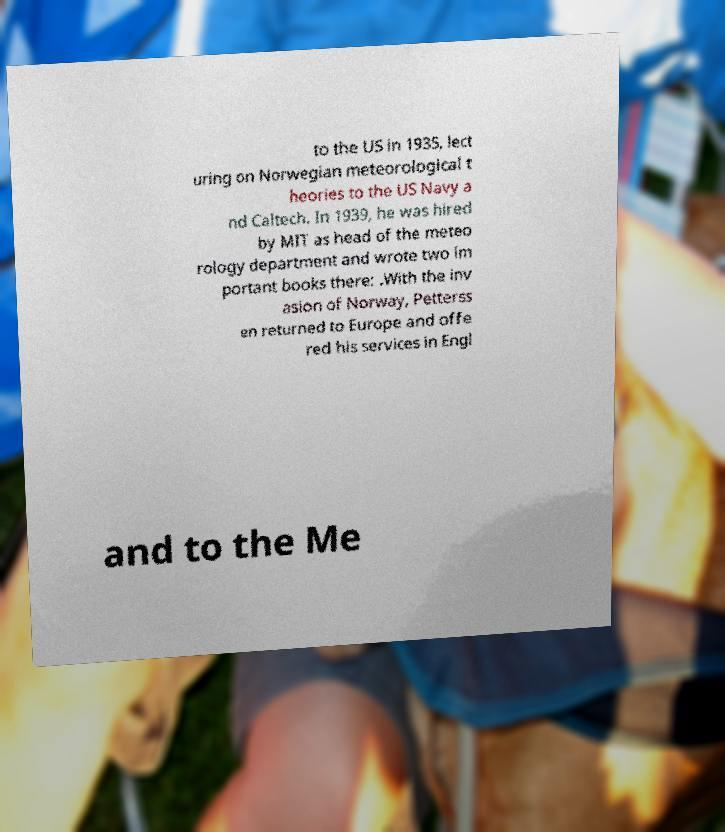Please read and relay the text visible in this image. What does it say? to the US in 1935, lect uring on Norwegian meteorological t heories to the US Navy a nd Caltech. In 1939, he was hired by MIT as head of the meteo rology department and wrote two im portant books there: .With the inv asion of Norway, Petterss en returned to Europe and offe red his services in Engl and to the Me 